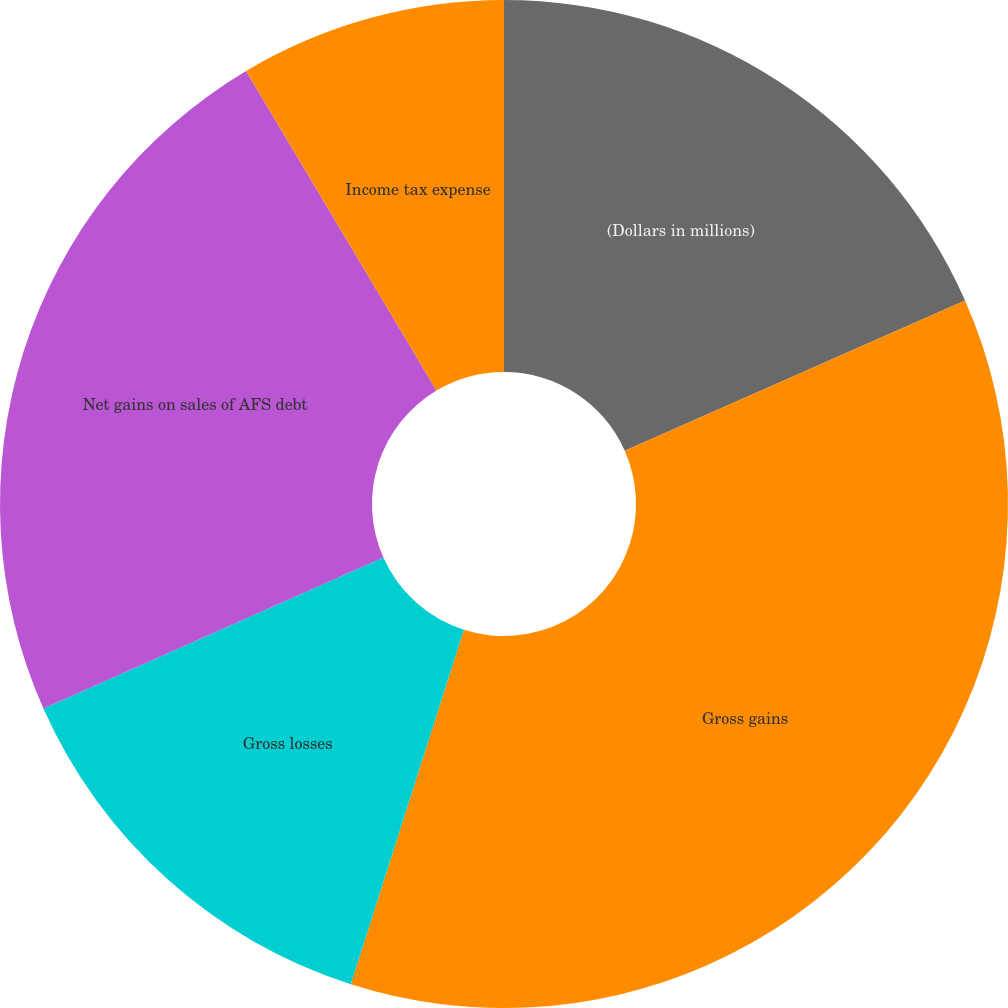Convert chart. <chart><loc_0><loc_0><loc_500><loc_500><pie_chart><fcel>(Dollars in millions)<fcel>Gross gains<fcel>Gross losses<fcel>Net gains on sales of AFS debt<fcel>Income tax expense<nl><fcel>18.38%<fcel>36.53%<fcel>13.43%<fcel>23.1%<fcel>8.55%<nl></chart> 